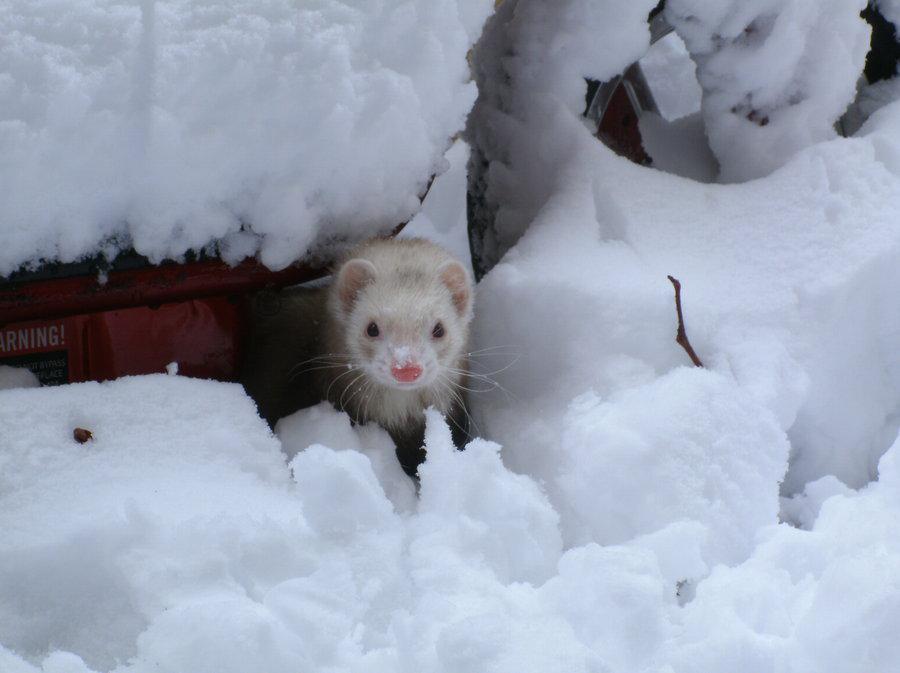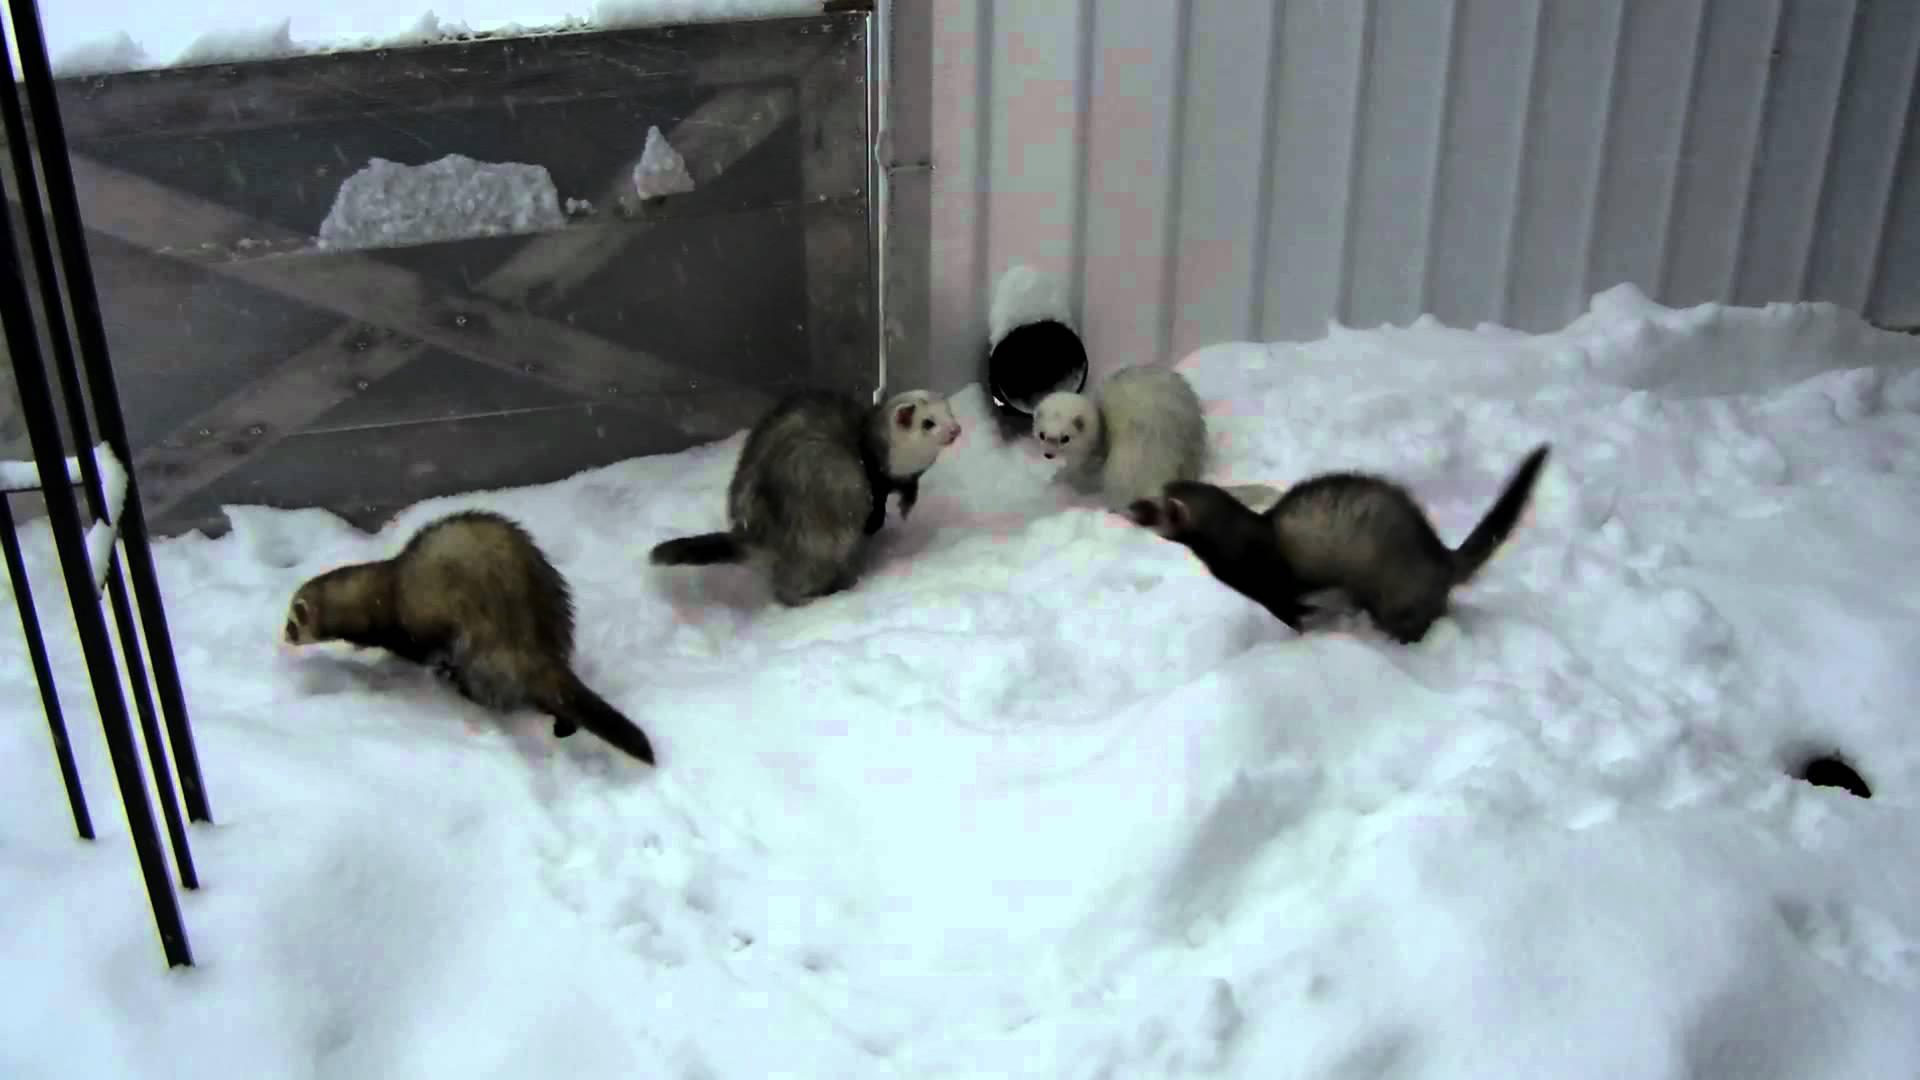The first image is the image on the left, the second image is the image on the right. For the images displayed, is the sentence "The animal in the image on the left is outside in the snow." factually correct? Answer yes or no. Yes. The first image is the image on the left, the second image is the image on the right. Assess this claim about the two images: "An image shows a ferret in a bowl of white fluff.". Correct or not? Answer yes or no. No. 